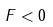Convert formula to latex. <formula><loc_0><loc_0><loc_500><loc_500>F < 0</formula> 